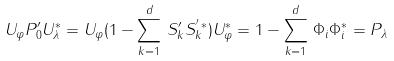<formula> <loc_0><loc_0><loc_500><loc_500>U _ { \varphi } P ^ { \prime } _ { 0 } U _ { \lambda } ^ { * } = U _ { \varphi } ( 1 - \sum _ { k = 1 } ^ { d } \, S ^ { \prime } _ { k } S _ { k } ^ { ^ { \prime } \, * } ) U _ { \varphi } ^ { * } = 1 - \sum _ { k = 1 } ^ { d } \, \Phi _ { i } \Phi _ { i } ^ { * } = P _ { \lambda }</formula> 